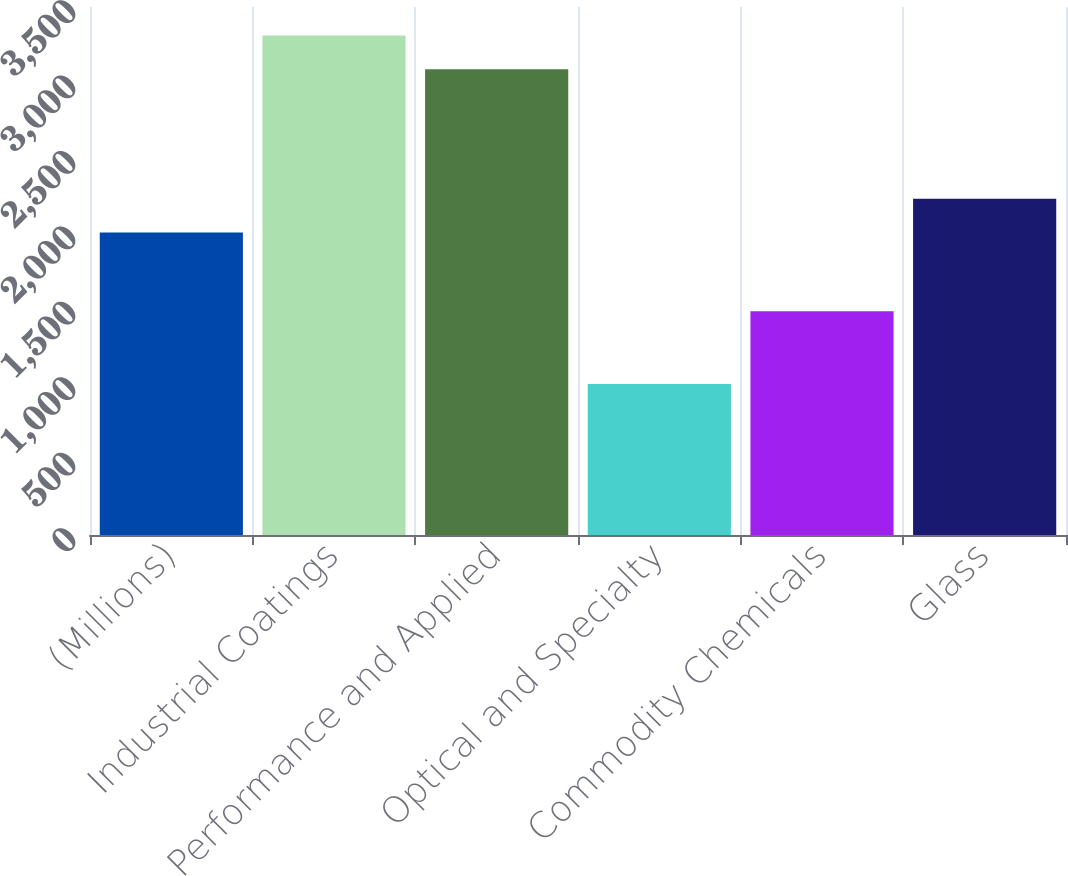Convert chart. <chart><loc_0><loc_0><loc_500><loc_500><bar_chart><fcel>(Millions)<fcel>Industrial Coatings<fcel>Performance and Applied<fcel>Optical and Specialty<fcel>Commodity Chemicals<fcel>Glass<nl><fcel>2006<fcel>3311.5<fcel>3088<fcel>1001<fcel>1483<fcel>2229.5<nl></chart> 